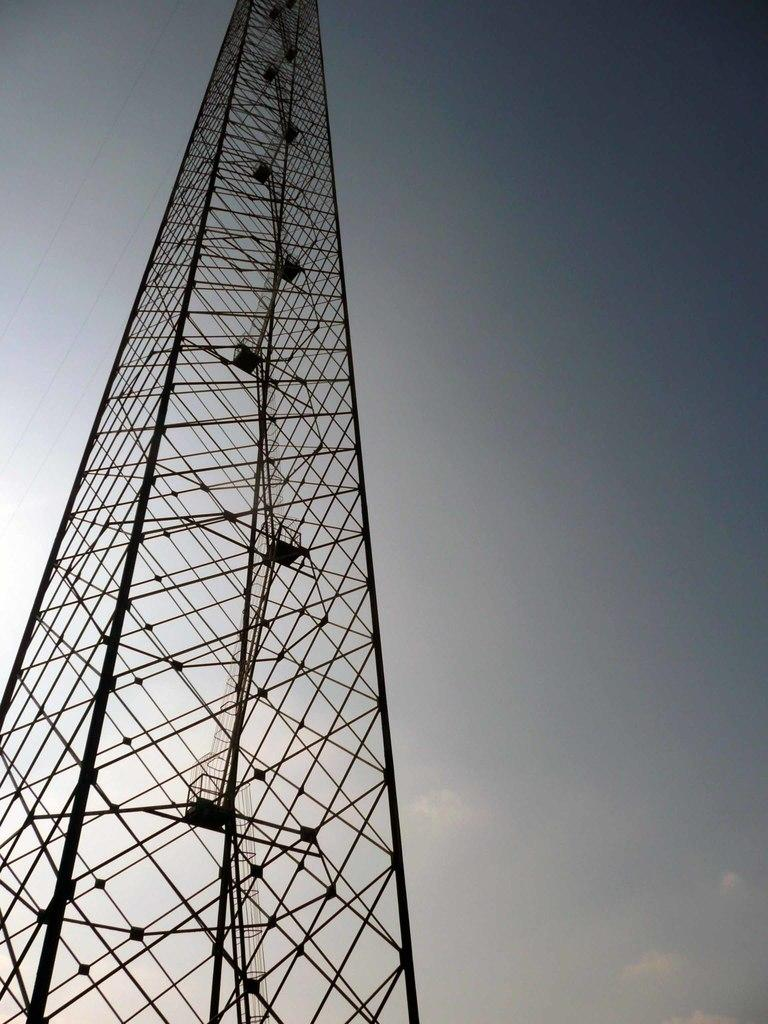What is the main structure in the image? There is a tower in the image. What can be seen in the background of the image? The sky is visible in the background of the image. How does the nail contribute to the growth of the tower in the image? There is no nail present in the image, and therefore no such contribution can be observed. 